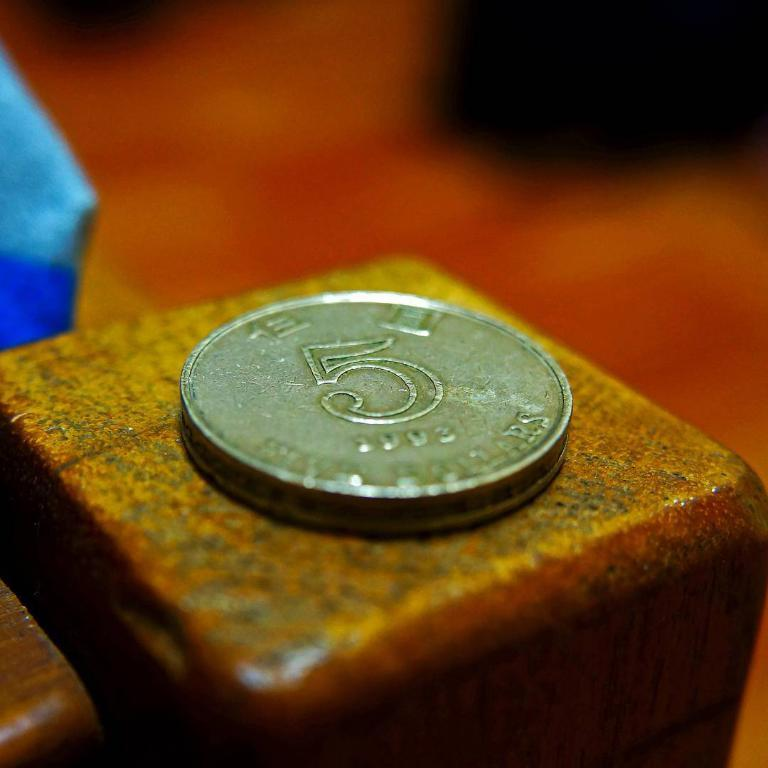Provide a one-sentence caption for the provided image. A 5 cent coin is resting on a wooden block. 